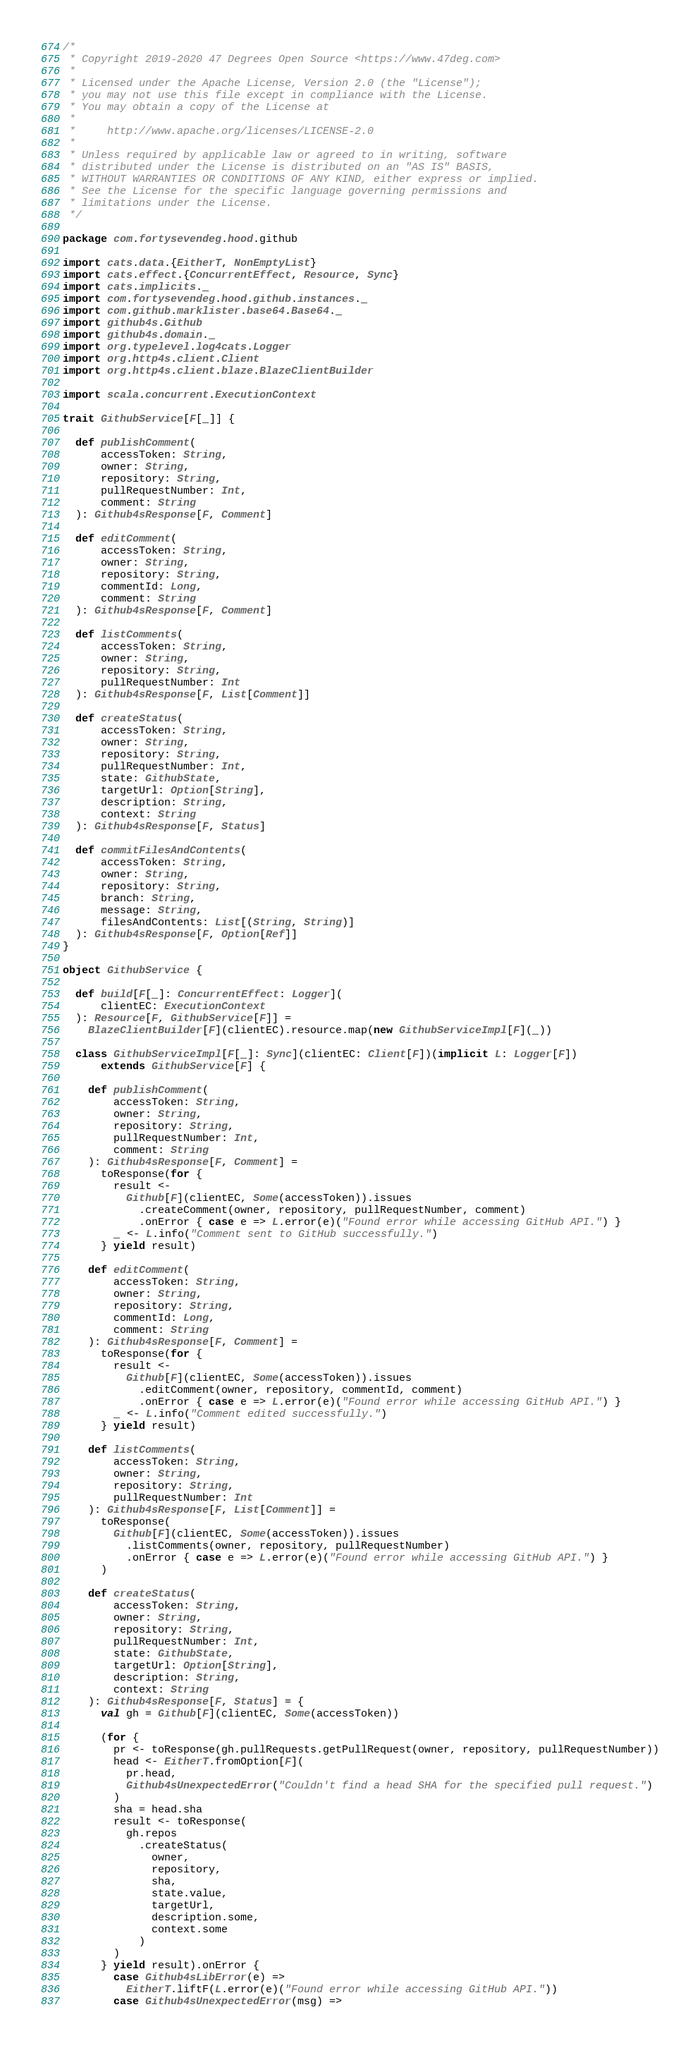<code> <loc_0><loc_0><loc_500><loc_500><_Scala_>/*
 * Copyright 2019-2020 47 Degrees Open Source <https://www.47deg.com>
 *
 * Licensed under the Apache License, Version 2.0 (the "License");
 * you may not use this file except in compliance with the License.
 * You may obtain a copy of the License at
 *
 *     http://www.apache.org/licenses/LICENSE-2.0
 *
 * Unless required by applicable law or agreed to in writing, software
 * distributed under the License is distributed on an "AS IS" BASIS,
 * WITHOUT WARRANTIES OR CONDITIONS OF ANY KIND, either express or implied.
 * See the License for the specific language governing permissions and
 * limitations under the License.
 */

package com.fortysevendeg.hood.github

import cats.data.{EitherT, NonEmptyList}
import cats.effect.{ConcurrentEffect, Resource, Sync}
import cats.implicits._
import com.fortysevendeg.hood.github.instances._
import com.github.marklister.base64.Base64._
import github4s.Github
import github4s.domain._
import org.typelevel.log4cats.Logger
import org.http4s.client.Client
import org.http4s.client.blaze.BlazeClientBuilder

import scala.concurrent.ExecutionContext

trait GithubService[F[_]] {

  def publishComment(
      accessToken: String,
      owner: String,
      repository: String,
      pullRequestNumber: Int,
      comment: String
  ): Github4sResponse[F, Comment]

  def editComment(
      accessToken: String,
      owner: String,
      repository: String,
      commentId: Long,
      comment: String
  ): Github4sResponse[F, Comment]

  def listComments(
      accessToken: String,
      owner: String,
      repository: String,
      pullRequestNumber: Int
  ): Github4sResponse[F, List[Comment]]

  def createStatus(
      accessToken: String,
      owner: String,
      repository: String,
      pullRequestNumber: Int,
      state: GithubState,
      targetUrl: Option[String],
      description: String,
      context: String
  ): Github4sResponse[F, Status]

  def commitFilesAndContents(
      accessToken: String,
      owner: String,
      repository: String,
      branch: String,
      message: String,
      filesAndContents: List[(String, String)]
  ): Github4sResponse[F, Option[Ref]]
}

object GithubService {

  def build[F[_]: ConcurrentEffect: Logger](
      clientEC: ExecutionContext
  ): Resource[F, GithubService[F]] =
    BlazeClientBuilder[F](clientEC).resource.map(new GithubServiceImpl[F](_))

  class GithubServiceImpl[F[_]: Sync](clientEC: Client[F])(implicit L: Logger[F])
      extends GithubService[F] {

    def publishComment(
        accessToken: String,
        owner: String,
        repository: String,
        pullRequestNumber: Int,
        comment: String
    ): Github4sResponse[F, Comment] =
      toResponse(for {
        result <-
          Github[F](clientEC, Some(accessToken)).issues
            .createComment(owner, repository, pullRequestNumber, comment)
            .onError { case e => L.error(e)("Found error while accessing GitHub API.") }
        _ <- L.info("Comment sent to GitHub successfully.")
      } yield result)

    def editComment(
        accessToken: String,
        owner: String,
        repository: String,
        commentId: Long,
        comment: String
    ): Github4sResponse[F, Comment] =
      toResponse(for {
        result <-
          Github[F](clientEC, Some(accessToken)).issues
            .editComment(owner, repository, commentId, comment)
            .onError { case e => L.error(e)("Found error while accessing GitHub API.") }
        _ <- L.info("Comment edited successfully.")
      } yield result)

    def listComments(
        accessToken: String,
        owner: String,
        repository: String,
        pullRequestNumber: Int
    ): Github4sResponse[F, List[Comment]] =
      toResponse(
        Github[F](clientEC, Some(accessToken)).issues
          .listComments(owner, repository, pullRequestNumber)
          .onError { case e => L.error(e)("Found error while accessing GitHub API.") }
      )

    def createStatus(
        accessToken: String,
        owner: String,
        repository: String,
        pullRequestNumber: Int,
        state: GithubState,
        targetUrl: Option[String],
        description: String,
        context: String
    ): Github4sResponse[F, Status] = {
      val gh = Github[F](clientEC, Some(accessToken))

      (for {
        pr <- toResponse(gh.pullRequests.getPullRequest(owner, repository, pullRequestNumber))
        head <- EitherT.fromOption[F](
          pr.head,
          Github4sUnexpectedError("Couldn't find a head SHA for the specified pull request.")
        )
        sha = head.sha
        result <- toResponse(
          gh.repos
            .createStatus(
              owner,
              repository,
              sha,
              state.value,
              targetUrl,
              description.some,
              context.some
            )
        )
      } yield result).onError {
        case Github4sLibError(e) =>
          EitherT.liftF(L.error(e)("Found error while accessing GitHub API."))
        case Github4sUnexpectedError(msg) =></code> 